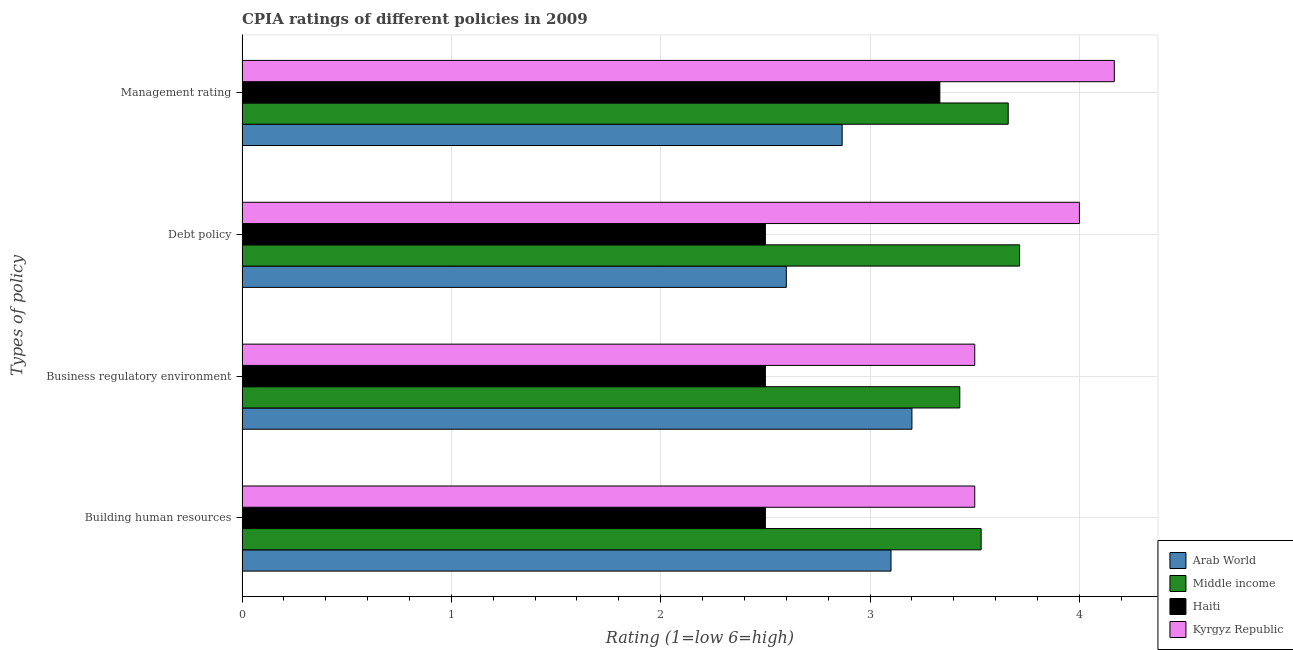How many bars are there on the 3rd tick from the top?
Offer a terse response. 4. What is the label of the 2nd group of bars from the top?
Your answer should be very brief. Debt policy. Across all countries, what is the minimum cpia rating of management?
Make the answer very short. 2.87. In which country was the cpia rating of business regulatory environment maximum?
Make the answer very short. Kyrgyz Republic. In which country was the cpia rating of management minimum?
Your answer should be compact. Arab World. What is the total cpia rating of building human resources in the graph?
Offer a very short reply. 12.63. What is the difference between the cpia rating of business regulatory environment in Kyrgyz Republic and that in Arab World?
Give a very brief answer. 0.3. What is the difference between the cpia rating of management in Haiti and the cpia rating of business regulatory environment in Middle income?
Ensure brevity in your answer.  -0.1. What is the average cpia rating of management per country?
Keep it short and to the point. 3.51. What is the difference between the cpia rating of business regulatory environment and cpia rating of management in Middle income?
Your response must be concise. -0.23. What is the ratio of the cpia rating of business regulatory environment in Middle income to that in Kyrgyz Republic?
Make the answer very short. 0.98. What is the difference between the highest and the second highest cpia rating of debt policy?
Give a very brief answer. 0.29. What is the difference between the highest and the lowest cpia rating of building human resources?
Offer a very short reply. 1.03. Is the sum of the cpia rating of debt policy in Kyrgyz Republic and Middle income greater than the maximum cpia rating of management across all countries?
Ensure brevity in your answer.  Yes. Is it the case that in every country, the sum of the cpia rating of management and cpia rating of business regulatory environment is greater than the sum of cpia rating of building human resources and cpia rating of debt policy?
Offer a terse response. No. What does the 1st bar from the top in Debt policy represents?
Your answer should be compact. Kyrgyz Republic. What does the 4th bar from the bottom in Building human resources represents?
Keep it short and to the point. Kyrgyz Republic. Is it the case that in every country, the sum of the cpia rating of building human resources and cpia rating of business regulatory environment is greater than the cpia rating of debt policy?
Offer a terse response. Yes. How many bars are there?
Keep it short and to the point. 16. Are all the bars in the graph horizontal?
Your answer should be compact. Yes. Does the graph contain grids?
Your answer should be compact. Yes. Where does the legend appear in the graph?
Ensure brevity in your answer.  Bottom right. How many legend labels are there?
Ensure brevity in your answer.  4. What is the title of the graph?
Your answer should be compact. CPIA ratings of different policies in 2009. Does "Netherlands" appear as one of the legend labels in the graph?
Offer a very short reply. No. What is the label or title of the X-axis?
Offer a terse response. Rating (1=low 6=high). What is the label or title of the Y-axis?
Your response must be concise. Types of policy. What is the Rating (1=low 6=high) of Middle income in Building human resources?
Your answer should be very brief. 3.53. What is the Rating (1=low 6=high) in Haiti in Building human resources?
Keep it short and to the point. 2.5. What is the Rating (1=low 6=high) of Arab World in Business regulatory environment?
Offer a very short reply. 3.2. What is the Rating (1=low 6=high) of Middle income in Business regulatory environment?
Ensure brevity in your answer.  3.43. What is the Rating (1=low 6=high) in Kyrgyz Republic in Business regulatory environment?
Make the answer very short. 3.5. What is the Rating (1=low 6=high) in Arab World in Debt policy?
Your answer should be very brief. 2.6. What is the Rating (1=low 6=high) of Middle income in Debt policy?
Your answer should be compact. 3.71. What is the Rating (1=low 6=high) of Haiti in Debt policy?
Provide a short and direct response. 2.5. What is the Rating (1=low 6=high) in Kyrgyz Republic in Debt policy?
Provide a short and direct response. 4. What is the Rating (1=low 6=high) in Arab World in Management rating?
Ensure brevity in your answer.  2.87. What is the Rating (1=low 6=high) of Middle income in Management rating?
Your response must be concise. 3.66. What is the Rating (1=low 6=high) of Haiti in Management rating?
Ensure brevity in your answer.  3.33. What is the Rating (1=low 6=high) in Kyrgyz Republic in Management rating?
Provide a short and direct response. 4.17. Across all Types of policy, what is the maximum Rating (1=low 6=high) in Arab World?
Give a very brief answer. 3.2. Across all Types of policy, what is the maximum Rating (1=low 6=high) in Middle income?
Provide a succinct answer. 3.71. Across all Types of policy, what is the maximum Rating (1=low 6=high) of Haiti?
Offer a terse response. 3.33. Across all Types of policy, what is the maximum Rating (1=low 6=high) in Kyrgyz Republic?
Give a very brief answer. 4.17. Across all Types of policy, what is the minimum Rating (1=low 6=high) of Middle income?
Offer a very short reply. 3.43. Across all Types of policy, what is the minimum Rating (1=low 6=high) of Haiti?
Your answer should be very brief. 2.5. What is the total Rating (1=low 6=high) of Arab World in the graph?
Give a very brief answer. 11.77. What is the total Rating (1=low 6=high) in Middle income in the graph?
Offer a terse response. 14.33. What is the total Rating (1=low 6=high) in Haiti in the graph?
Provide a succinct answer. 10.83. What is the total Rating (1=low 6=high) in Kyrgyz Republic in the graph?
Your answer should be compact. 15.17. What is the difference between the Rating (1=low 6=high) of Middle income in Building human resources and that in Business regulatory environment?
Offer a terse response. 0.1. What is the difference between the Rating (1=low 6=high) in Haiti in Building human resources and that in Business regulatory environment?
Your response must be concise. 0. What is the difference between the Rating (1=low 6=high) of Kyrgyz Republic in Building human resources and that in Business regulatory environment?
Provide a short and direct response. 0. What is the difference between the Rating (1=low 6=high) in Middle income in Building human resources and that in Debt policy?
Keep it short and to the point. -0.18. What is the difference between the Rating (1=low 6=high) of Arab World in Building human resources and that in Management rating?
Provide a short and direct response. 0.23. What is the difference between the Rating (1=low 6=high) of Middle income in Building human resources and that in Management rating?
Offer a terse response. -0.13. What is the difference between the Rating (1=low 6=high) in Haiti in Building human resources and that in Management rating?
Give a very brief answer. -0.83. What is the difference between the Rating (1=low 6=high) in Middle income in Business regulatory environment and that in Debt policy?
Provide a short and direct response. -0.29. What is the difference between the Rating (1=low 6=high) of Haiti in Business regulatory environment and that in Debt policy?
Offer a terse response. 0. What is the difference between the Rating (1=low 6=high) of Kyrgyz Republic in Business regulatory environment and that in Debt policy?
Provide a short and direct response. -0.5. What is the difference between the Rating (1=low 6=high) in Middle income in Business regulatory environment and that in Management rating?
Provide a succinct answer. -0.23. What is the difference between the Rating (1=low 6=high) of Arab World in Debt policy and that in Management rating?
Provide a short and direct response. -0.27. What is the difference between the Rating (1=low 6=high) in Middle income in Debt policy and that in Management rating?
Offer a terse response. 0.05. What is the difference between the Rating (1=low 6=high) of Haiti in Debt policy and that in Management rating?
Keep it short and to the point. -0.83. What is the difference between the Rating (1=low 6=high) in Arab World in Building human resources and the Rating (1=low 6=high) in Middle income in Business regulatory environment?
Give a very brief answer. -0.33. What is the difference between the Rating (1=low 6=high) in Arab World in Building human resources and the Rating (1=low 6=high) in Haiti in Business regulatory environment?
Provide a short and direct response. 0.6. What is the difference between the Rating (1=low 6=high) of Arab World in Building human resources and the Rating (1=low 6=high) of Kyrgyz Republic in Business regulatory environment?
Provide a succinct answer. -0.4. What is the difference between the Rating (1=low 6=high) of Middle income in Building human resources and the Rating (1=low 6=high) of Haiti in Business regulatory environment?
Provide a succinct answer. 1.03. What is the difference between the Rating (1=low 6=high) of Middle income in Building human resources and the Rating (1=low 6=high) of Kyrgyz Republic in Business regulatory environment?
Make the answer very short. 0.03. What is the difference between the Rating (1=low 6=high) of Haiti in Building human resources and the Rating (1=low 6=high) of Kyrgyz Republic in Business regulatory environment?
Offer a very short reply. -1. What is the difference between the Rating (1=low 6=high) in Arab World in Building human resources and the Rating (1=low 6=high) in Middle income in Debt policy?
Your answer should be very brief. -0.61. What is the difference between the Rating (1=low 6=high) in Arab World in Building human resources and the Rating (1=low 6=high) in Haiti in Debt policy?
Keep it short and to the point. 0.6. What is the difference between the Rating (1=low 6=high) of Arab World in Building human resources and the Rating (1=low 6=high) of Kyrgyz Republic in Debt policy?
Keep it short and to the point. -0.9. What is the difference between the Rating (1=low 6=high) of Middle income in Building human resources and the Rating (1=low 6=high) of Haiti in Debt policy?
Provide a succinct answer. 1.03. What is the difference between the Rating (1=low 6=high) in Middle income in Building human resources and the Rating (1=low 6=high) in Kyrgyz Republic in Debt policy?
Give a very brief answer. -0.47. What is the difference between the Rating (1=low 6=high) in Arab World in Building human resources and the Rating (1=low 6=high) in Middle income in Management rating?
Provide a succinct answer. -0.56. What is the difference between the Rating (1=low 6=high) of Arab World in Building human resources and the Rating (1=low 6=high) of Haiti in Management rating?
Keep it short and to the point. -0.23. What is the difference between the Rating (1=low 6=high) of Arab World in Building human resources and the Rating (1=low 6=high) of Kyrgyz Republic in Management rating?
Keep it short and to the point. -1.07. What is the difference between the Rating (1=low 6=high) of Middle income in Building human resources and the Rating (1=low 6=high) of Haiti in Management rating?
Ensure brevity in your answer.  0.2. What is the difference between the Rating (1=low 6=high) in Middle income in Building human resources and the Rating (1=low 6=high) in Kyrgyz Republic in Management rating?
Offer a very short reply. -0.64. What is the difference between the Rating (1=low 6=high) in Haiti in Building human resources and the Rating (1=low 6=high) in Kyrgyz Republic in Management rating?
Give a very brief answer. -1.67. What is the difference between the Rating (1=low 6=high) of Arab World in Business regulatory environment and the Rating (1=low 6=high) of Middle income in Debt policy?
Give a very brief answer. -0.51. What is the difference between the Rating (1=low 6=high) in Arab World in Business regulatory environment and the Rating (1=low 6=high) in Haiti in Debt policy?
Keep it short and to the point. 0.7. What is the difference between the Rating (1=low 6=high) of Middle income in Business regulatory environment and the Rating (1=low 6=high) of Kyrgyz Republic in Debt policy?
Provide a succinct answer. -0.57. What is the difference between the Rating (1=low 6=high) in Arab World in Business regulatory environment and the Rating (1=low 6=high) in Middle income in Management rating?
Make the answer very short. -0.46. What is the difference between the Rating (1=low 6=high) of Arab World in Business regulatory environment and the Rating (1=low 6=high) of Haiti in Management rating?
Offer a terse response. -0.13. What is the difference between the Rating (1=low 6=high) of Arab World in Business regulatory environment and the Rating (1=low 6=high) of Kyrgyz Republic in Management rating?
Offer a very short reply. -0.97. What is the difference between the Rating (1=low 6=high) in Middle income in Business regulatory environment and the Rating (1=low 6=high) in Haiti in Management rating?
Provide a short and direct response. 0.1. What is the difference between the Rating (1=low 6=high) of Middle income in Business regulatory environment and the Rating (1=low 6=high) of Kyrgyz Republic in Management rating?
Your answer should be compact. -0.74. What is the difference between the Rating (1=low 6=high) of Haiti in Business regulatory environment and the Rating (1=low 6=high) of Kyrgyz Republic in Management rating?
Keep it short and to the point. -1.67. What is the difference between the Rating (1=low 6=high) of Arab World in Debt policy and the Rating (1=low 6=high) of Middle income in Management rating?
Your answer should be compact. -1.06. What is the difference between the Rating (1=low 6=high) in Arab World in Debt policy and the Rating (1=low 6=high) in Haiti in Management rating?
Provide a succinct answer. -0.73. What is the difference between the Rating (1=low 6=high) of Arab World in Debt policy and the Rating (1=low 6=high) of Kyrgyz Republic in Management rating?
Provide a short and direct response. -1.57. What is the difference between the Rating (1=low 6=high) in Middle income in Debt policy and the Rating (1=low 6=high) in Haiti in Management rating?
Your answer should be compact. 0.38. What is the difference between the Rating (1=low 6=high) of Middle income in Debt policy and the Rating (1=low 6=high) of Kyrgyz Republic in Management rating?
Your answer should be very brief. -0.45. What is the difference between the Rating (1=low 6=high) of Haiti in Debt policy and the Rating (1=low 6=high) of Kyrgyz Republic in Management rating?
Offer a very short reply. -1.67. What is the average Rating (1=low 6=high) of Arab World per Types of policy?
Provide a short and direct response. 2.94. What is the average Rating (1=low 6=high) of Middle income per Types of policy?
Ensure brevity in your answer.  3.58. What is the average Rating (1=low 6=high) in Haiti per Types of policy?
Offer a very short reply. 2.71. What is the average Rating (1=low 6=high) in Kyrgyz Republic per Types of policy?
Offer a terse response. 3.79. What is the difference between the Rating (1=low 6=high) in Arab World and Rating (1=low 6=high) in Middle income in Building human resources?
Your response must be concise. -0.43. What is the difference between the Rating (1=low 6=high) in Arab World and Rating (1=low 6=high) in Haiti in Building human resources?
Ensure brevity in your answer.  0.6. What is the difference between the Rating (1=low 6=high) of Middle income and Rating (1=low 6=high) of Haiti in Building human resources?
Provide a succinct answer. 1.03. What is the difference between the Rating (1=low 6=high) of Middle income and Rating (1=low 6=high) of Kyrgyz Republic in Building human resources?
Ensure brevity in your answer.  0.03. What is the difference between the Rating (1=low 6=high) in Haiti and Rating (1=low 6=high) in Kyrgyz Republic in Building human resources?
Give a very brief answer. -1. What is the difference between the Rating (1=low 6=high) of Arab World and Rating (1=low 6=high) of Middle income in Business regulatory environment?
Provide a short and direct response. -0.23. What is the difference between the Rating (1=low 6=high) of Middle income and Rating (1=low 6=high) of Haiti in Business regulatory environment?
Make the answer very short. 0.93. What is the difference between the Rating (1=low 6=high) in Middle income and Rating (1=low 6=high) in Kyrgyz Republic in Business regulatory environment?
Your answer should be compact. -0.07. What is the difference between the Rating (1=low 6=high) of Haiti and Rating (1=low 6=high) of Kyrgyz Republic in Business regulatory environment?
Your answer should be very brief. -1. What is the difference between the Rating (1=low 6=high) in Arab World and Rating (1=low 6=high) in Middle income in Debt policy?
Offer a very short reply. -1.11. What is the difference between the Rating (1=low 6=high) of Arab World and Rating (1=low 6=high) of Kyrgyz Republic in Debt policy?
Ensure brevity in your answer.  -1.4. What is the difference between the Rating (1=low 6=high) of Middle income and Rating (1=low 6=high) of Haiti in Debt policy?
Give a very brief answer. 1.21. What is the difference between the Rating (1=low 6=high) of Middle income and Rating (1=low 6=high) of Kyrgyz Republic in Debt policy?
Give a very brief answer. -0.29. What is the difference between the Rating (1=low 6=high) in Haiti and Rating (1=low 6=high) in Kyrgyz Republic in Debt policy?
Your response must be concise. -1.5. What is the difference between the Rating (1=low 6=high) in Arab World and Rating (1=low 6=high) in Middle income in Management rating?
Your answer should be very brief. -0.79. What is the difference between the Rating (1=low 6=high) of Arab World and Rating (1=low 6=high) of Haiti in Management rating?
Provide a short and direct response. -0.47. What is the difference between the Rating (1=low 6=high) of Middle income and Rating (1=low 6=high) of Haiti in Management rating?
Ensure brevity in your answer.  0.33. What is the difference between the Rating (1=low 6=high) in Middle income and Rating (1=low 6=high) in Kyrgyz Republic in Management rating?
Your answer should be very brief. -0.51. What is the ratio of the Rating (1=low 6=high) of Arab World in Building human resources to that in Business regulatory environment?
Your answer should be compact. 0.97. What is the ratio of the Rating (1=low 6=high) in Middle income in Building human resources to that in Business regulatory environment?
Make the answer very short. 1.03. What is the ratio of the Rating (1=low 6=high) in Arab World in Building human resources to that in Debt policy?
Your response must be concise. 1.19. What is the ratio of the Rating (1=low 6=high) in Middle income in Building human resources to that in Debt policy?
Keep it short and to the point. 0.95. What is the ratio of the Rating (1=low 6=high) in Haiti in Building human resources to that in Debt policy?
Keep it short and to the point. 1. What is the ratio of the Rating (1=low 6=high) in Arab World in Building human resources to that in Management rating?
Your answer should be very brief. 1.08. What is the ratio of the Rating (1=low 6=high) in Middle income in Building human resources to that in Management rating?
Provide a short and direct response. 0.96. What is the ratio of the Rating (1=low 6=high) of Haiti in Building human resources to that in Management rating?
Provide a succinct answer. 0.75. What is the ratio of the Rating (1=low 6=high) of Kyrgyz Republic in Building human resources to that in Management rating?
Keep it short and to the point. 0.84. What is the ratio of the Rating (1=low 6=high) in Arab World in Business regulatory environment to that in Debt policy?
Offer a very short reply. 1.23. What is the ratio of the Rating (1=low 6=high) of Middle income in Business regulatory environment to that in Debt policy?
Give a very brief answer. 0.92. What is the ratio of the Rating (1=low 6=high) of Haiti in Business regulatory environment to that in Debt policy?
Make the answer very short. 1. What is the ratio of the Rating (1=low 6=high) in Arab World in Business regulatory environment to that in Management rating?
Provide a succinct answer. 1.12. What is the ratio of the Rating (1=low 6=high) in Middle income in Business regulatory environment to that in Management rating?
Give a very brief answer. 0.94. What is the ratio of the Rating (1=low 6=high) of Kyrgyz Republic in Business regulatory environment to that in Management rating?
Ensure brevity in your answer.  0.84. What is the ratio of the Rating (1=low 6=high) in Arab World in Debt policy to that in Management rating?
Your response must be concise. 0.91. What is the ratio of the Rating (1=low 6=high) in Middle income in Debt policy to that in Management rating?
Make the answer very short. 1.01. What is the ratio of the Rating (1=low 6=high) of Kyrgyz Republic in Debt policy to that in Management rating?
Ensure brevity in your answer.  0.96. What is the difference between the highest and the second highest Rating (1=low 6=high) of Middle income?
Provide a short and direct response. 0.05. What is the difference between the highest and the lowest Rating (1=low 6=high) of Arab World?
Keep it short and to the point. 0.6. What is the difference between the highest and the lowest Rating (1=low 6=high) of Middle income?
Ensure brevity in your answer.  0.29. What is the difference between the highest and the lowest Rating (1=low 6=high) of Kyrgyz Republic?
Give a very brief answer. 0.67. 